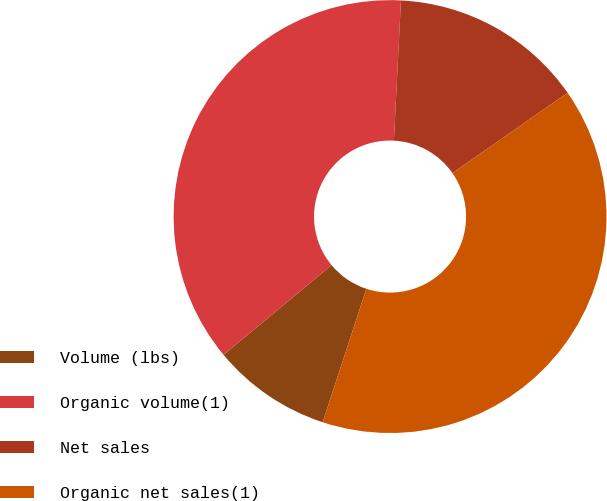<chart> <loc_0><loc_0><loc_500><loc_500><pie_chart><fcel>Volume (lbs)<fcel>Organic volume(1)<fcel>Net sales<fcel>Organic net sales(1)<nl><fcel>8.93%<fcel>36.83%<fcel>14.51%<fcel>39.73%<nl></chart> 